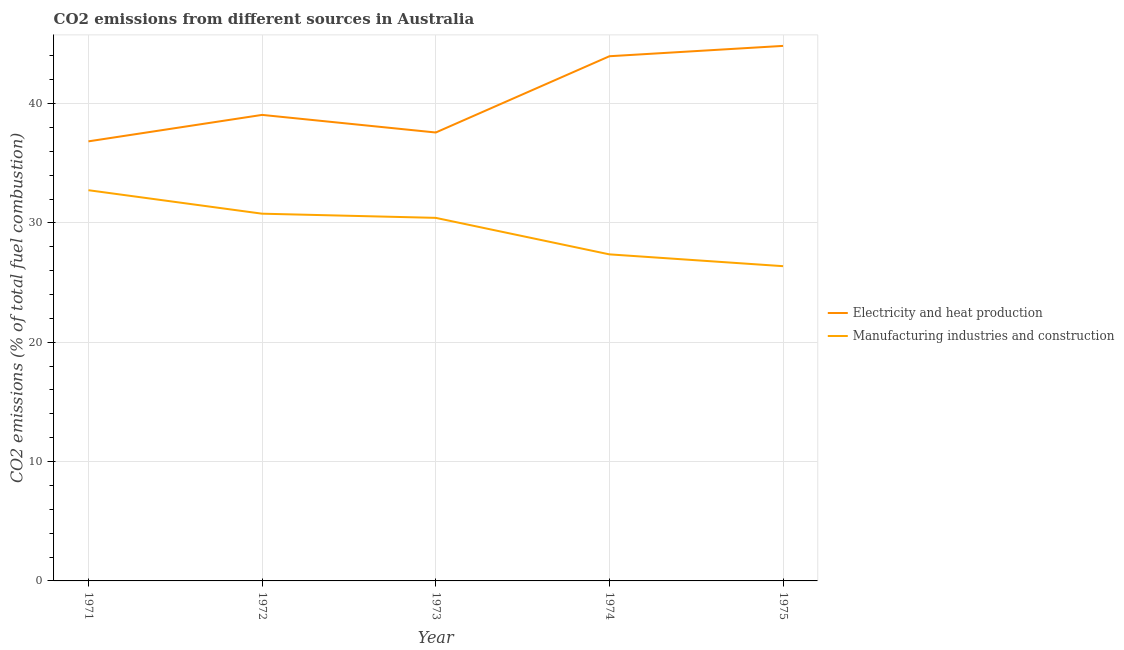How many different coloured lines are there?
Your answer should be compact. 2. Is the number of lines equal to the number of legend labels?
Provide a short and direct response. Yes. What is the co2 emissions due to manufacturing industries in 1975?
Your response must be concise. 26.37. Across all years, what is the maximum co2 emissions due to manufacturing industries?
Your response must be concise. 32.74. Across all years, what is the minimum co2 emissions due to manufacturing industries?
Make the answer very short. 26.37. In which year was the co2 emissions due to manufacturing industries maximum?
Your answer should be very brief. 1971. What is the total co2 emissions due to manufacturing industries in the graph?
Make the answer very short. 147.67. What is the difference between the co2 emissions due to manufacturing industries in 1972 and that in 1975?
Provide a short and direct response. 4.4. What is the difference between the co2 emissions due to manufacturing industries in 1974 and the co2 emissions due to electricity and heat production in 1971?
Offer a very short reply. -9.47. What is the average co2 emissions due to manufacturing industries per year?
Provide a short and direct response. 29.53. In the year 1971, what is the difference between the co2 emissions due to electricity and heat production and co2 emissions due to manufacturing industries?
Your answer should be compact. 4.09. In how many years, is the co2 emissions due to manufacturing industries greater than 8 %?
Your answer should be very brief. 5. What is the ratio of the co2 emissions due to electricity and heat production in 1972 to that in 1974?
Provide a short and direct response. 0.89. Is the co2 emissions due to manufacturing industries in 1971 less than that in 1972?
Your response must be concise. No. What is the difference between the highest and the second highest co2 emissions due to electricity and heat production?
Your response must be concise. 0.87. What is the difference between the highest and the lowest co2 emissions due to electricity and heat production?
Your response must be concise. 8. Does the co2 emissions due to manufacturing industries monotonically increase over the years?
Offer a very short reply. No. Is the co2 emissions due to electricity and heat production strictly greater than the co2 emissions due to manufacturing industries over the years?
Your answer should be very brief. Yes. Is the co2 emissions due to manufacturing industries strictly less than the co2 emissions due to electricity and heat production over the years?
Your answer should be compact. Yes. What is the difference between two consecutive major ticks on the Y-axis?
Your answer should be very brief. 10. Are the values on the major ticks of Y-axis written in scientific E-notation?
Offer a terse response. No. Where does the legend appear in the graph?
Offer a terse response. Center right. What is the title of the graph?
Offer a very short reply. CO2 emissions from different sources in Australia. What is the label or title of the Y-axis?
Your answer should be very brief. CO2 emissions (% of total fuel combustion). What is the CO2 emissions (% of total fuel combustion) of Electricity and heat production in 1971?
Offer a terse response. 36.83. What is the CO2 emissions (% of total fuel combustion) in Manufacturing industries and construction in 1971?
Provide a succinct answer. 32.74. What is the CO2 emissions (% of total fuel combustion) of Electricity and heat production in 1972?
Provide a succinct answer. 39.05. What is the CO2 emissions (% of total fuel combustion) in Manufacturing industries and construction in 1972?
Your answer should be very brief. 30.77. What is the CO2 emissions (% of total fuel combustion) in Electricity and heat production in 1973?
Give a very brief answer. 37.57. What is the CO2 emissions (% of total fuel combustion) in Manufacturing industries and construction in 1973?
Make the answer very short. 30.42. What is the CO2 emissions (% of total fuel combustion) of Electricity and heat production in 1974?
Offer a terse response. 43.96. What is the CO2 emissions (% of total fuel combustion) of Manufacturing industries and construction in 1974?
Keep it short and to the point. 27.36. What is the CO2 emissions (% of total fuel combustion) of Electricity and heat production in 1975?
Your answer should be very brief. 44.83. What is the CO2 emissions (% of total fuel combustion) in Manufacturing industries and construction in 1975?
Your answer should be compact. 26.37. Across all years, what is the maximum CO2 emissions (% of total fuel combustion) of Electricity and heat production?
Provide a short and direct response. 44.83. Across all years, what is the maximum CO2 emissions (% of total fuel combustion) in Manufacturing industries and construction?
Offer a very short reply. 32.74. Across all years, what is the minimum CO2 emissions (% of total fuel combustion) of Electricity and heat production?
Offer a very short reply. 36.83. Across all years, what is the minimum CO2 emissions (% of total fuel combustion) of Manufacturing industries and construction?
Provide a short and direct response. 26.37. What is the total CO2 emissions (% of total fuel combustion) in Electricity and heat production in the graph?
Ensure brevity in your answer.  202.25. What is the total CO2 emissions (% of total fuel combustion) in Manufacturing industries and construction in the graph?
Keep it short and to the point. 147.67. What is the difference between the CO2 emissions (% of total fuel combustion) of Electricity and heat production in 1971 and that in 1972?
Provide a succinct answer. -2.22. What is the difference between the CO2 emissions (% of total fuel combustion) in Manufacturing industries and construction in 1971 and that in 1972?
Your response must be concise. 1.97. What is the difference between the CO2 emissions (% of total fuel combustion) in Electricity and heat production in 1971 and that in 1973?
Keep it short and to the point. -0.74. What is the difference between the CO2 emissions (% of total fuel combustion) in Manufacturing industries and construction in 1971 and that in 1973?
Offer a very short reply. 2.32. What is the difference between the CO2 emissions (% of total fuel combustion) in Electricity and heat production in 1971 and that in 1974?
Your answer should be very brief. -7.13. What is the difference between the CO2 emissions (% of total fuel combustion) in Manufacturing industries and construction in 1971 and that in 1974?
Give a very brief answer. 5.38. What is the difference between the CO2 emissions (% of total fuel combustion) in Electricity and heat production in 1971 and that in 1975?
Offer a very short reply. -8. What is the difference between the CO2 emissions (% of total fuel combustion) in Manufacturing industries and construction in 1971 and that in 1975?
Keep it short and to the point. 6.37. What is the difference between the CO2 emissions (% of total fuel combustion) of Electricity and heat production in 1972 and that in 1973?
Ensure brevity in your answer.  1.48. What is the difference between the CO2 emissions (% of total fuel combustion) in Manufacturing industries and construction in 1972 and that in 1973?
Provide a short and direct response. 0.35. What is the difference between the CO2 emissions (% of total fuel combustion) in Electricity and heat production in 1972 and that in 1974?
Your answer should be compact. -4.91. What is the difference between the CO2 emissions (% of total fuel combustion) of Manufacturing industries and construction in 1972 and that in 1974?
Your answer should be very brief. 3.41. What is the difference between the CO2 emissions (% of total fuel combustion) in Electricity and heat production in 1972 and that in 1975?
Ensure brevity in your answer.  -5.78. What is the difference between the CO2 emissions (% of total fuel combustion) in Manufacturing industries and construction in 1972 and that in 1975?
Make the answer very short. 4.4. What is the difference between the CO2 emissions (% of total fuel combustion) of Electricity and heat production in 1973 and that in 1974?
Your answer should be compact. -6.39. What is the difference between the CO2 emissions (% of total fuel combustion) in Manufacturing industries and construction in 1973 and that in 1974?
Ensure brevity in your answer.  3.06. What is the difference between the CO2 emissions (% of total fuel combustion) of Electricity and heat production in 1973 and that in 1975?
Provide a succinct answer. -7.26. What is the difference between the CO2 emissions (% of total fuel combustion) in Manufacturing industries and construction in 1973 and that in 1975?
Provide a succinct answer. 4.05. What is the difference between the CO2 emissions (% of total fuel combustion) of Electricity and heat production in 1974 and that in 1975?
Provide a short and direct response. -0.87. What is the difference between the CO2 emissions (% of total fuel combustion) of Manufacturing industries and construction in 1974 and that in 1975?
Your answer should be compact. 0.99. What is the difference between the CO2 emissions (% of total fuel combustion) in Electricity and heat production in 1971 and the CO2 emissions (% of total fuel combustion) in Manufacturing industries and construction in 1972?
Offer a very short reply. 6.06. What is the difference between the CO2 emissions (% of total fuel combustion) in Electricity and heat production in 1971 and the CO2 emissions (% of total fuel combustion) in Manufacturing industries and construction in 1973?
Keep it short and to the point. 6.41. What is the difference between the CO2 emissions (% of total fuel combustion) in Electricity and heat production in 1971 and the CO2 emissions (% of total fuel combustion) in Manufacturing industries and construction in 1974?
Your response must be concise. 9.47. What is the difference between the CO2 emissions (% of total fuel combustion) of Electricity and heat production in 1971 and the CO2 emissions (% of total fuel combustion) of Manufacturing industries and construction in 1975?
Offer a very short reply. 10.46. What is the difference between the CO2 emissions (% of total fuel combustion) of Electricity and heat production in 1972 and the CO2 emissions (% of total fuel combustion) of Manufacturing industries and construction in 1973?
Your answer should be very brief. 8.63. What is the difference between the CO2 emissions (% of total fuel combustion) in Electricity and heat production in 1972 and the CO2 emissions (% of total fuel combustion) in Manufacturing industries and construction in 1974?
Your answer should be very brief. 11.69. What is the difference between the CO2 emissions (% of total fuel combustion) in Electricity and heat production in 1972 and the CO2 emissions (% of total fuel combustion) in Manufacturing industries and construction in 1975?
Provide a short and direct response. 12.68. What is the difference between the CO2 emissions (% of total fuel combustion) of Electricity and heat production in 1973 and the CO2 emissions (% of total fuel combustion) of Manufacturing industries and construction in 1974?
Offer a terse response. 10.21. What is the difference between the CO2 emissions (% of total fuel combustion) of Electricity and heat production in 1973 and the CO2 emissions (% of total fuel combustion) of Manufacturing industries and construction in 1975?
Make the answer very short. 11.2. What is the difference between the CO2 emissions (% of total fuel combustion) of Electricity and heat production in 1974 and the CO2 emissions (% of total fuel combustion) of Manufacturing industries and construction in 1975?
Your response must be concise. 17.59. What is the average CO2 emissions (% of total fuel combustion) in Electricity and heat production per year?
Make the answer very short. 40.45. What is the average CO2 emissions (% of total fuel combustion) in Manufacturing industries and construction per year?
Offer a very short reply. 29.53. In the year 1971, what is the difference between the CO2 emissions (% of total fuel combustion) in Electricity and heat production and CO2 emissions (% of total fuel combustion) in Manufacturing industries and construction?
Your response must be concise. 4.09. In the year 1972, what is the difference between the CO2 emissions (% of total fuel combustion) of Electricity and heat production and CO2 emissions (% of total fuel combustion) of Manufacturing industries and construction?
Provide a short and direct response. 8.28. In the year 1973, what is the difference between the CO2 emissions (% of total fuel combustion) of Electricity and heat production and CO2 emissions (% of total fuel combustion) of Manufacturing industries and construction?
Ensure brevity in your answer.  7.15. In the year 1974, what is the difference between the CO2 emissions (% of total fuel combustion) in Electricity and heat production and CO2 emissions (% of total fuel combustion) in Manufacturing industries and construction?
Provide a succinct answer. 16.6. In the year 1975, what is the difference between the CO2 emissions (% of total fuel combustion) in Electricity and heat production and CO2 emissions (% of total fuel combustion) in Manufacturing industries and construction?
Offer a terse response. 18.46. What is the ratio of the CO2 emissions (% of total fuel combustion) in Electricity and heat production in 1971 to that in 1972?
Offer a terse response. 0.94. What is the ratio of the CO2 emissions (% of total fuel combustion) in Manufacturing industries and construction in 1971 to that in 1972?
Give a very brief answer. 1.06. What is the ratio of the CO2 emissions (% of total fuel combustion) in Electricity and heat production in 1971 to that in 1973?
Your answer should be compact. 0.98. What is the ratio of the CO2 emissions (% of total fuel combustion) of Manufacturing industries and construction in 1971 to that in 1973?
Make the answer very short. 1.08. What is the ratio of the CO2 emissions (% of total fuel combustion) in Electricity and heat production in 1971 to that in 1974?
Make the answer very short. 0.84. What is the ratio of the CO2 emissions (% of total fuel combustion) of Manufacturing industries and construction in 1971 to that in 1974?
Your response must be concise. 1.2. What is the ratio of the CO2 emissions (% of total fuel combustion) of Electricity and heat production in 1971 to that in 1975?
Your response must be concise. 0.82. What is the ratio of the CO2 emissions (% of total fuel combustion) in Manufacturing industries and construction in 1971 to that in 1975?
Offer a very short reply. 1.24. What is the ratio of the CO2 emissions (% of total fuel combustion) in Electricity and heat production in 1972 to that in 1973?
Offer a very short reply. 1.04. What is the ratio of the CO2 emissions (% of total fuel combustion) of Manufacturing industries and construction in 1972 to that in 1973?
Keep it short and to the point. 1.01. What is the ratio of the CO2 emissions (% of total fuel combustion) in Electricity and heat production in 1972 to that in 1974?
Give a very brief answer. 0.89. What is the ratio of the CO2 emissions (% of total fuel combustion) of Manufacturing industries and construction in 1972 to that in 1974?
Make the answer very short. 1.12. What is the ratio of the CO2 emissions (% of total fuel combustion) of Electricity and heat production in 1972 to that in 1975?
Your answer should be compact. 0.87. What is the ratio of the CO2 emissions (% of total fuel combustion) of Electricity and heat production in 1973 to that in 1974?
Give a very brief answer. 0.85. What is the ratio of the CO2 emissions (% of total fuel combustion) of Manufacturing industries and construction in 1973 to that in 1974?
Your response must be concise. 1.11. What is the ratio of the CO2 emissions (% of total fuel combustion) of Electricity and heat production in 1973 to that in 1975?
Provide a short and direct response. 0.84. What is the ratio of the CO2 emissions (% of total fuel combustion) in Manufacturing industries and construction in 1973 to that in 1975?
Give a very brief answer. 1.15. What is the ratio of the CO2 emissions (% of total fuel combustion) in Electricity and heat production in 1974 to that in 1975?
Your answer should be very brief. 0.98. What is the ratio of the CO2 emissions (% of total fuel combustion) of Manufacturing industries and construction in 1974 to that in 1975?
Offer a terse response. 1.04. What is the difference between the highest and the second highest CO2 emissions (% of total fuel combustion) of Electricity and heat production?
Keep it short and to the point. 0.87. What is the difference between the highest and the second highest CO2 emissions (% of total fuel combustion) of Manufacturing industries and construction?
Provide a short and direct response. 1.97. What is the difference between the highest and the lowest CO2 emissions (% of total fuel combustion) of Electricity and heat production?
Ensure brevity in your answer.  8. What is the difference between the highest and the lowest CO2 emissions (% of total fuel combustion) in Manufacturing industries and construction?
Keep it short and to the point. 6.37. 